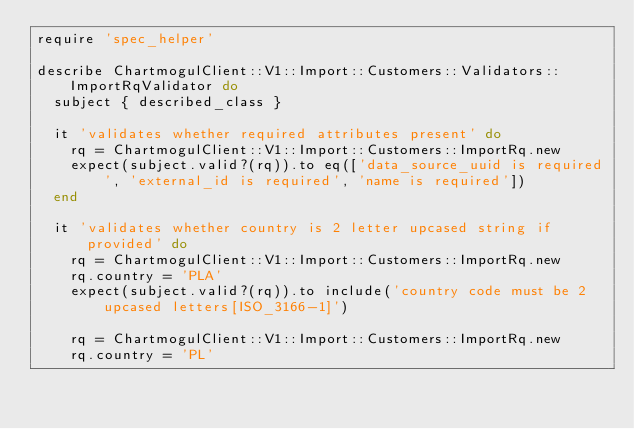Convert code to text. <code><loc_0><loc_0><loc_500><loc_500><_Ruby_>require 'spec_helper'

describe ChartmogulClient::V1::Import::Customers::Validators::ImportRqValidator do
  subject { described_class }

  it 'validates whether required attributes present' do
    rq = ChartmogulClient::V1::Import::Customers::ImportRq.new
    expect(subject.valid?(rq)).to eq(['data_source_uuid is required', 'external_id is required', 'name is required'])
  end

  it 'validates whether country is 2 letter upcased string if provided' do
    rq = ChartmogulClient::V1::Import::Customers::ImportRq.new
    rq.country = 'PLA'
    expect(subject.valid?(rq)).to include('country code must be 2 upcased letters[ISO_3166-1]')

    rq = ChartmogulClient::V1::Import::Customers::ImportRq.new
    rq.country = 'PL'</code> 